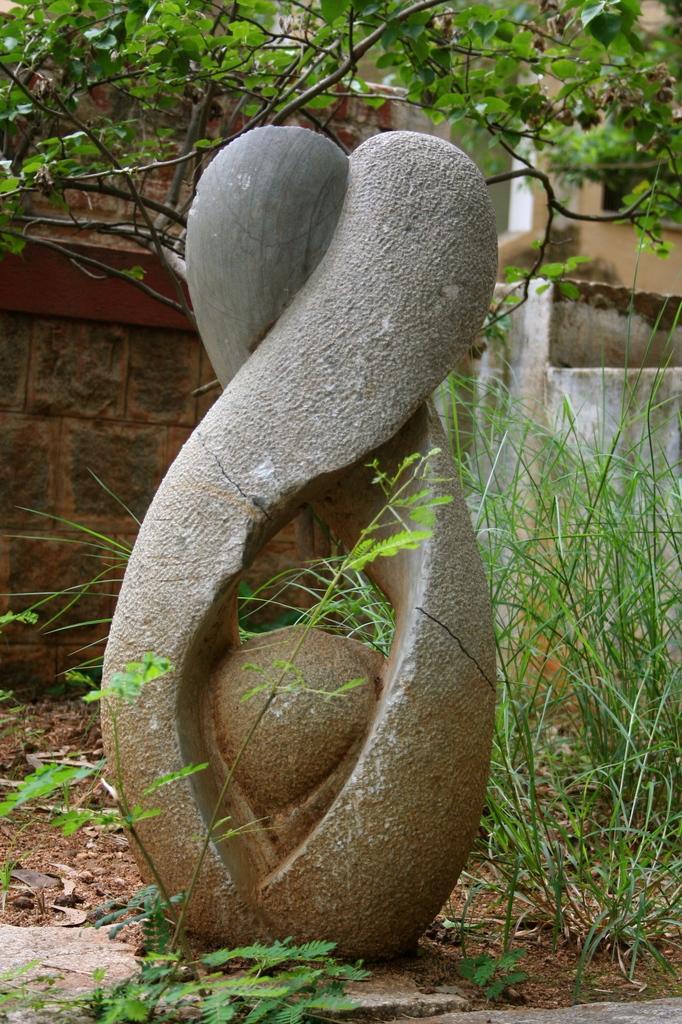Can you describe this image briefly? Here there are trees, this is an object. 